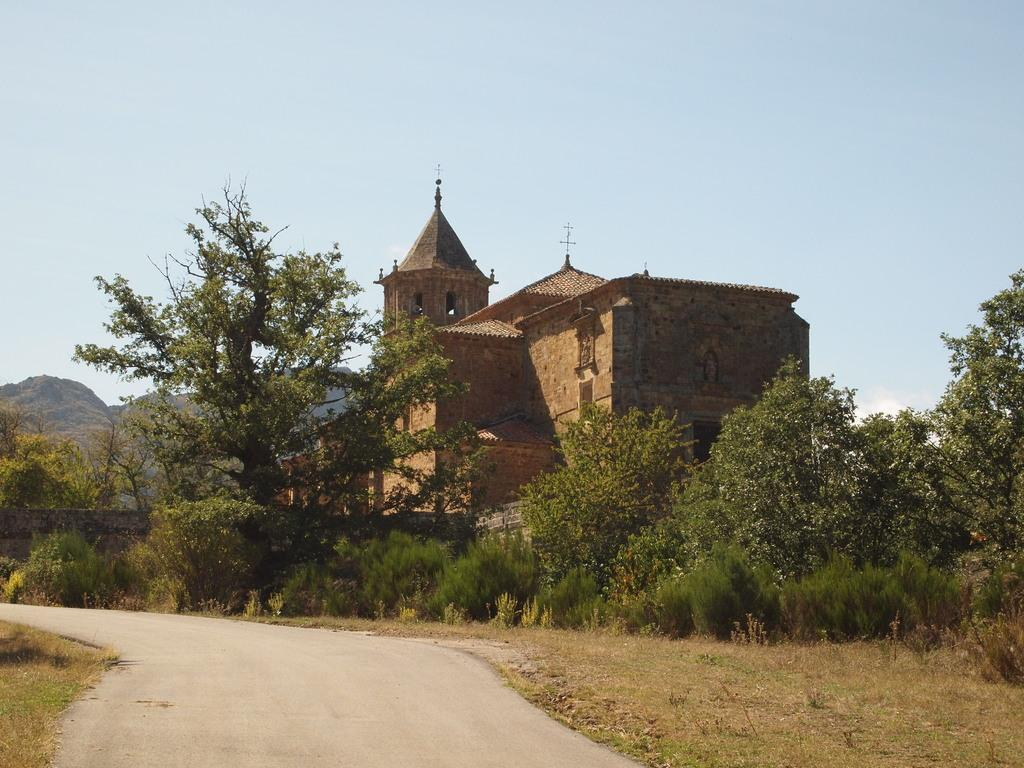What type of terrain is visible in the image? There is a plain road in the image. What can be seen alongside the road? There are many plants and trees around the road. What structure is located behind the trees? There is a building behind the trees. What natural feature can be seen in the distance? There are mountains visible in the background. What type of trade is happening between the trees in the image? There is no trade happening between the trees in the image; they are simply trees. 